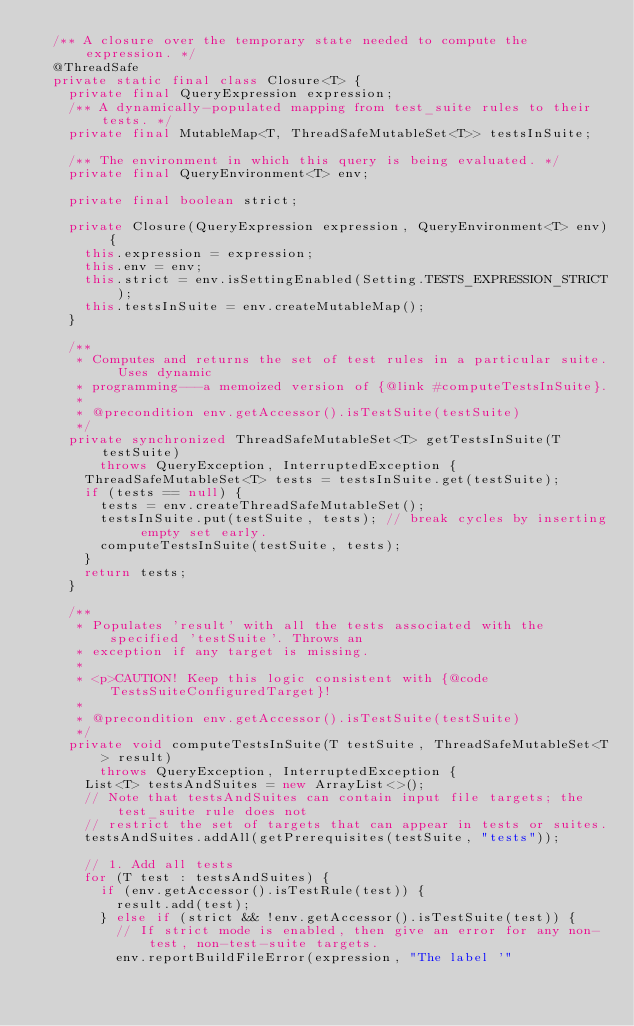Convert code to text. <code><loc_0><loc_0><loc_500><loc_500><_Java_>  /** A closure over the temporary state needed to compute the expression. */
  @ThreadSafe
  private static final class Closure<T> {
    private final QueryExpression expression;
    /** A dynamically-populated mapping from test_suite rules to their tests. */
    private final MutableMap<T, ThreadSafeMutableSet<T>> testsInSuite;

    /** The environment in which this query is being evaluated. */
    private final QueryEnvironment<T> env;

    private final boolean strict;

    private Closure(QueryExpression expression, QueryEnvironment<T> env) {
      this.expression = expression;
      this.env = env;
      this.strict = env.isSettingEnabled(Setting.TESTS_EXPRESSION_STRICT);
      this.testsInSuite = env.createMutableMap();
    }

    /**
     * Computes and returns the set of test rules in a particular suite. Uses dynamic
     * programming---a memoized version of {@link #computeTestsInSuite}.
     *
     * @precondition env.getAccessor().isTestSuite(testSuite)
     */
    private synchronized ThreadSafeMutableSet<T> getTestsInSuite(T testSuite)
        throws QueryException, InterruptedException {
      ThreadSafeMutableSet<T> tests = testsInSuite.get(testSuite);
      if (tests == null) {
        tests = env.createThreadSafeMutableSet();
        testsInSuite.put(testSuite, tests); // break cycles by inserting empty set early.
        computeTestsInSuite(testSuite, tests);
      }
      return tests;
    }

    /**
     * Populates 'result' with all the tests associated with the specified 'testSuite'. Throws an
     * exception if any target is missing.
     *
     * <p>CAUTION! Keep this logic consistent with {@code TestsSuiteConfiguredTarget}!
     *
     * @precondition env.getAccessor().isTestSuite(testSuite)
     */
    private void computeTestsInSuite(T testSuite, ThreadSafeMutableSet<T> result)
        throws QueryException, InterruptedException {
      List<T> testsAndSuites = new ArrayList<>();
      // Note that testsAndSuites can contain input file targets; the test_suite rule does not
      // restrict the set of targets that can appear in tests or suites.
      testsAndSuites.addAll(getPrerequisites(testSuite, "tests"));

      // 1. Add all tests
      for (T test : testsAndSuites) {
        if (env.getAccessor().isTestRule(test)) {
          result.add(test);
        } else if (strict && !env.getAccessor().isTestSuite(test)) {
          // If strict mode is enabled, then give an error for any non-test, non-test-suite targets.
          env.reportBuildFileError(expression, "The label '"</code> 